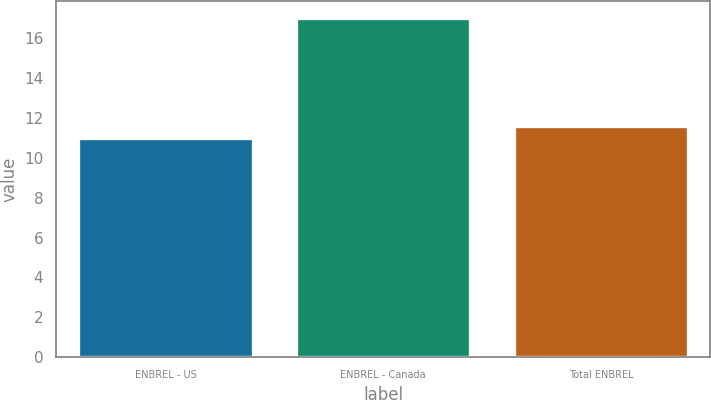Convert chart. <chart><loc_0><loc_0><loc_500><loc_500><bar_chart><fcel>ENBREL - US<fcel>ENBREL - Canada<fcel>Total ENBREL<nl><fcel>11<fcel>17<fcel>11.6<nl></chart> 